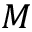Convert formula to latex. <formula><loc_0><loc_0><loc_500><loc_500>M</formula> 